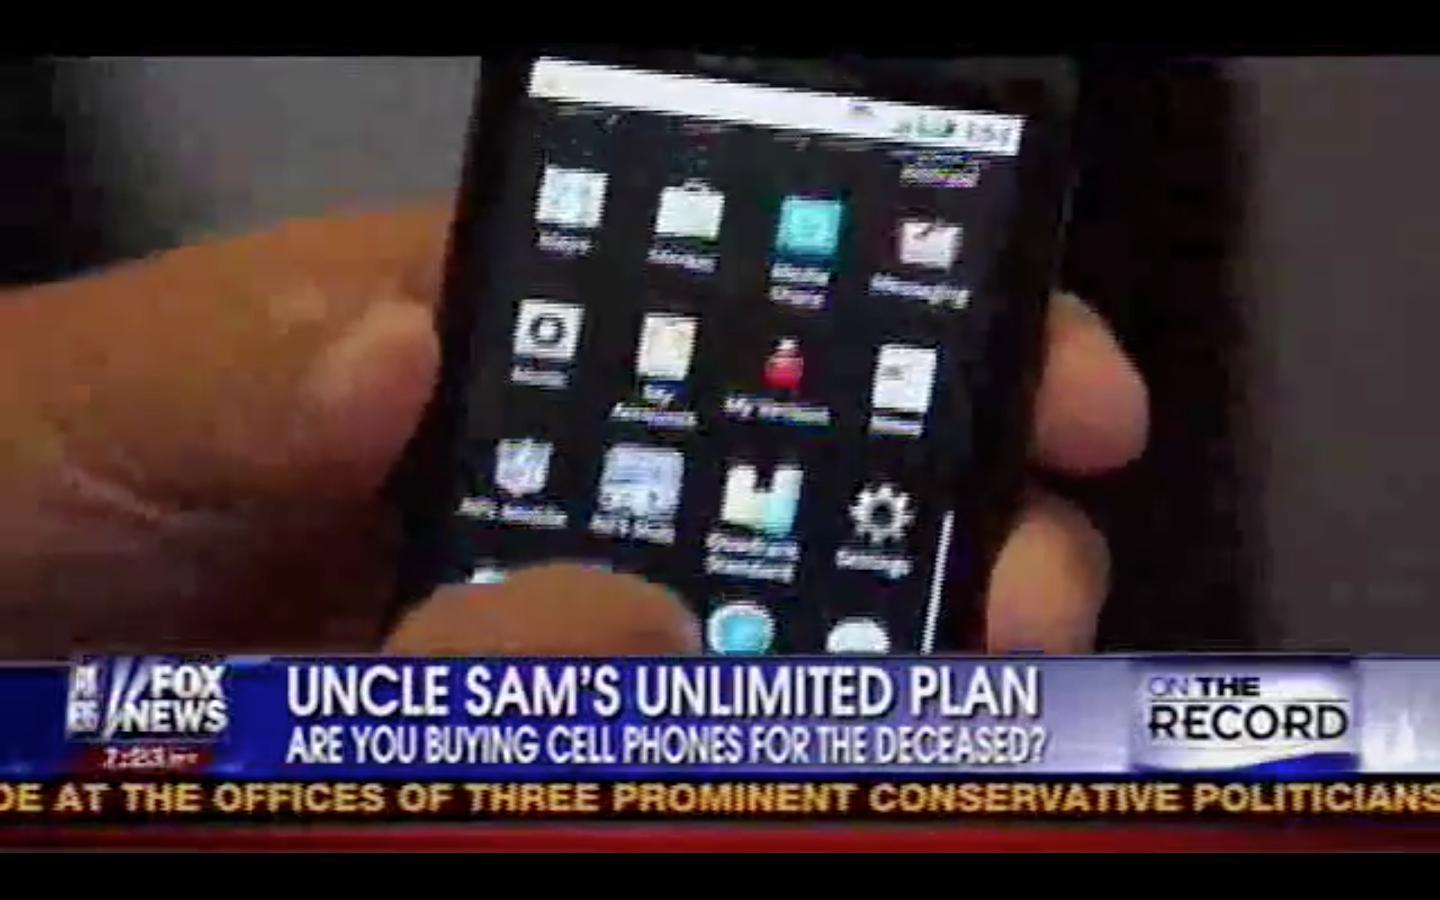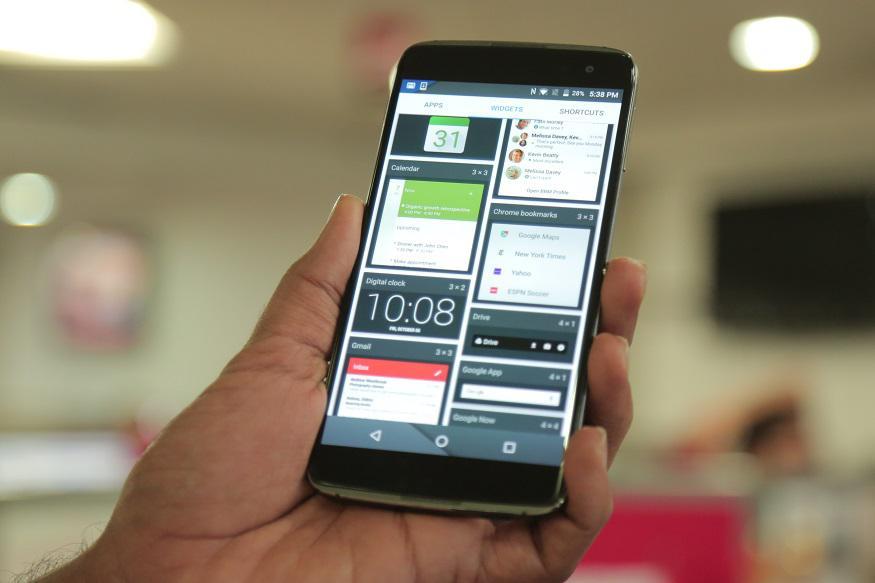The first image is the image on the left, the second image is the image on the right. Assess this claim about the two images: "A phone is being held by a person in each photo.". Correct or not? Answer yes or no. Yes. The first image is the image on the left, the second image is the image on the right. Given the left and right images, does the statement "The combined images include two hands, each holding a flat phone with a screen that nearly fills its front." hold true? Answer yes or no. Yes. 